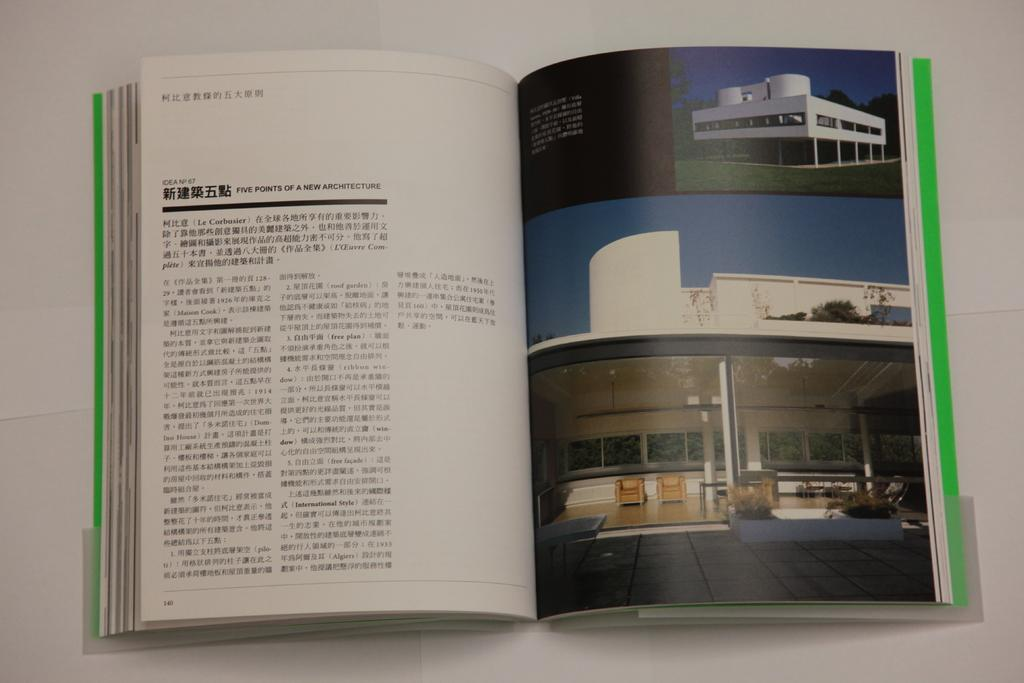<image>
Create a compact narrative representing the image presented. An architecture book is opened up to a page about the five points of a new architecture. 